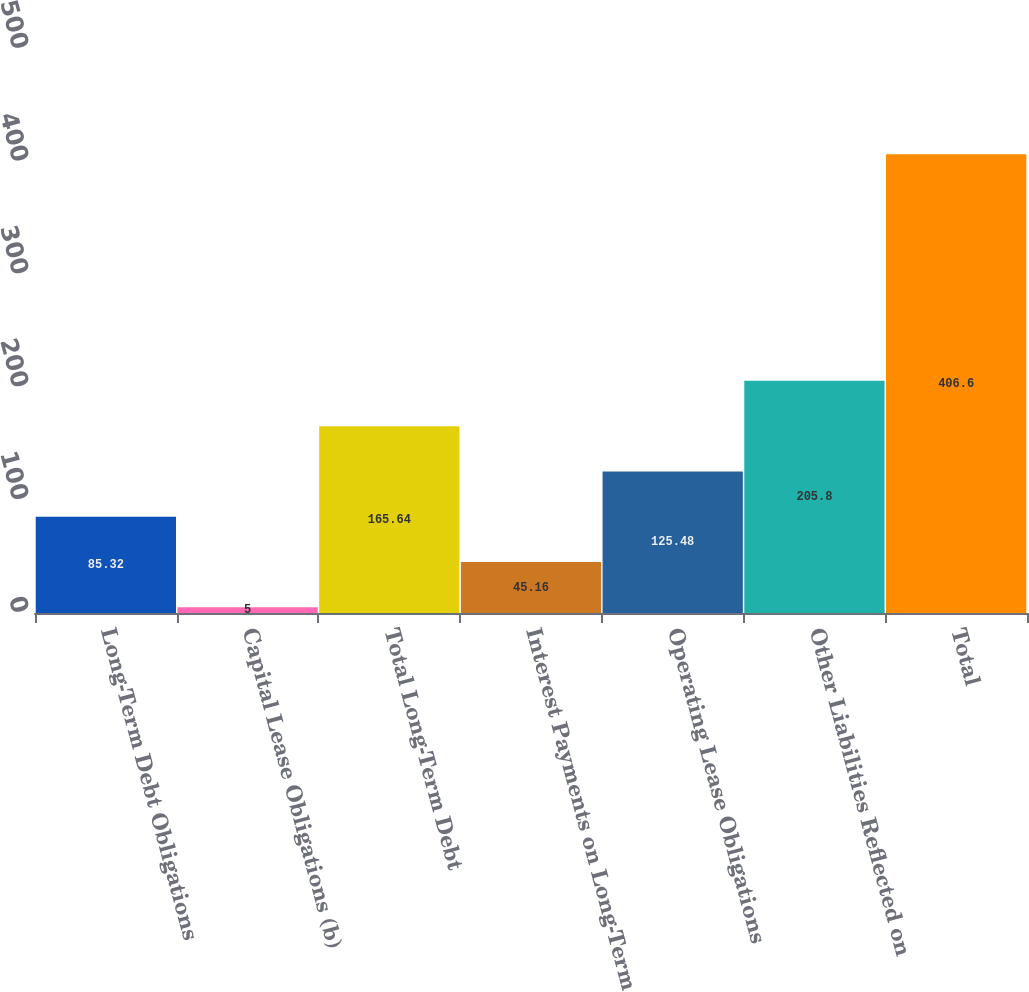Convert chart. <chart><loc_0><loc_0><loc_500><loc_500><bar_chart><fcel>Long-Term Debt Obligations<fcel>Capital Lease Obligations (b)<fcel>Total Long-Term Debt<fcel>Interest Payments on Long-Term<fcel>Operating Lease Obligations<fcel>Other Liabilities Reflected on<fcel>Total<nl><fcel>85.32<fcel>5<fcel>165.64<fcel>45.16<fcel>125.48<fcel>205.8<fcel>406.6<nl></chart> 